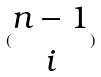Convert formula to latex. <formula><loc_0><loc_0><loc_500><loc_500>( \begin{matrix} n - 1 \\ i \end{matrix} )</formula> 